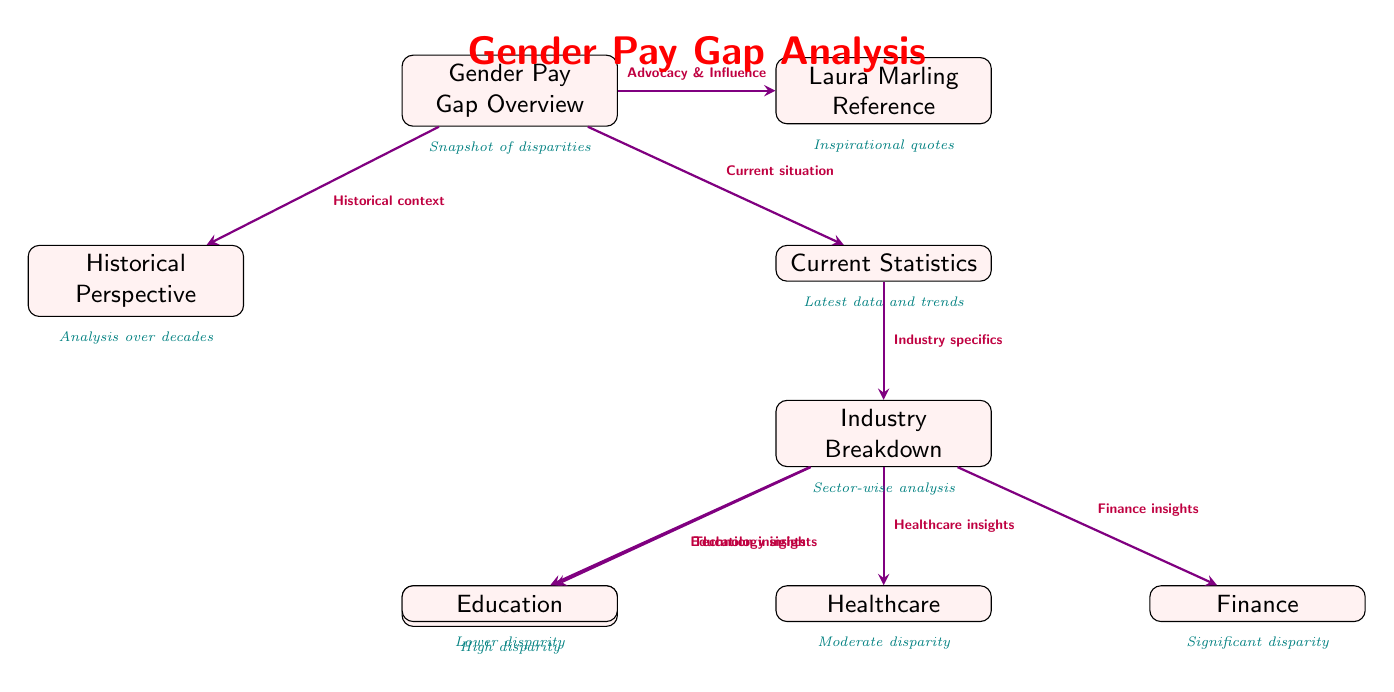What is the title of the diagram? The title of the diagram is located at the top and labeled clearly as "Gender Pay Gap Analysis." This is the header that encapsulates the entire content of the diagram, providing context for the information presented.
Answer: Gender Pay Gap Analysis How many main sections does the diagram have? The diagram features two main sections: "Historical Perspective" and "Current Statistics," which are positioned below the overview of the gender pay gap. This is determined by counting the distinct boxes that branch out from the overview node.
Answer: Two What connects the "Gender Pay Gap Overview" to "Current Statistics"? The connection is made by an arrow labeled "Current situation," which indicates the flow of information from the overall overview to the current statistics, showing that the current situation relates to the broader pay gap context.
Answer: Current situation Which industry has the highest reported disparity according to the diagram? The diagram indicates that "Technology" is listed with the description "High disparity" under the "Industry Breakdown" section, which suggests that it has the highest reported disparity of the industries mentioned.
Answer: Technology What are the four industries analyzed in this diagram? The four industries analyzed are "Technology," "Healthcare," "Finance," and "Education." This is inferred from the labels connected under the "Industry Breakdown" box, indicating sector-specific analysis of pay gaps.
Answer: Technology, Healthcare, Finance, Education What does the node labeled "Laura Marling Reference" suggest about the content? The node titled "Laura Marling Reference" suggests that inspirational quotes related to gender pay gap advocacy and influence are included in the diagram. This node connects to the overall gender pay gap overview, indicating a thematic linkage to the artist's perspective on gender rights.
Answer: Inspirational quotes What type of insights does the "Healthcare" box provide? The "Healthcare" box provides "Moderate disparity" insights, as indicated by the description located directly below the box in the diagram, specifically detailing the level of gender pay gap within that industry.
Answer: Moderate disparity Which aspect does the arrow from "Gender Pay Gap Overview" to "Historical Perspective" emphasize? The arrow labeled "Historical context" emphasizes that the historical perspective provides context and a timeline of changes regarding the gender pay gap over time, connecting understanding of history to the current analysis.
Answer: Historical context What type of analysis is shown in the "Industry Breakdown" section? The "Industry Breakdown" section shows a "Sector-wise analysis," as indicated by the label directly connecting it to the overview of current statistics. This indicates a detailed dissection of the pay gap across various sectors.
Answer: Sector-wise analysis 